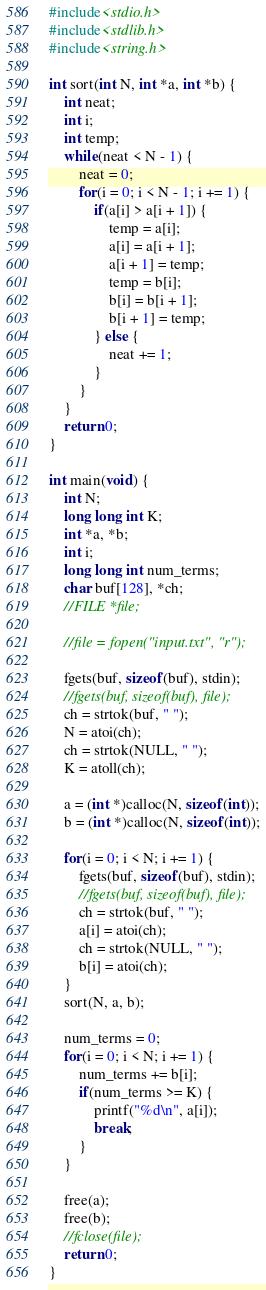<code> <loc_0><loc_0><loc_500><loc_500><_C_>#include<stdio.h>
#include<stdlib.h>
#include<string.h>

int sort(int N, int *a, int *b) {
	int neat;
	int i;
	int temp;
	while(neat < N - 1) {
		neat = 0;
		for(i = 0; i < N - 1; i += 1) {
			if(a[i] > a[i + 1]) {
				temp = a[i];
				a[i] = a[i + 1];
				a[i + 1] = temp;
				temp = b[i];
				b[i] = b[i + 1];
				b[i + 1] = temp;
			} else {
				neat += 1;
			}
		}
	}
	return 0;
}

int main(void) {
	int N;
	long long int K;
	int *a, *b;
	int i;
	long long int num_terms;
	char buf[128], *ch;
	//FILE *file;

	//file = fopen("input.txt", "r");

	fgets(buf, sizeof(buf), stdin);
	//fgets(buf, sizeof(buf), file);
	ch = strtok(buf, " ");
	N = atoi(ch);
	ch = strtok(NULL, " ");
	K = atoll(ch);

	a = (int *)calloc(N, sizeof(int));
	b = (int *)calloc(N, sizeof(int));

	for(i = 0; i < N; i += 1) {
		fgets(buf, sizeof(buf), stdin);
		//fgets(buf, sizeof(buf), file);
		ch = strtok(buf, " ");
		a[i] = atoi(ch);
		ch = strtok(NULL, " ");
		b[i] = atoi(ch);
	}
	sort(N, a, b);

	num_terms = 0;
	for(i = 0; i < N; i += 1) {
		num_terms += b[i];
		if(num_terms >= K) {
			printf("%d\n", a[i]);
			break;
		}
	}

	free(a);
	free(b);
	//fclose(file);
	return 0;
}
</code> 